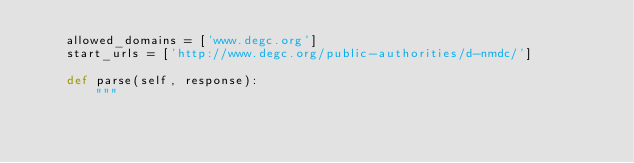<code> <loc_0><loc_0><loc_500><loc_500><_Python_>    allowed_domains = ['www.degc.org']
    start_urls = ['http://www.degc.org/public-authorities/d-nmdc/']

    def parse(self, response):
        """</code> 